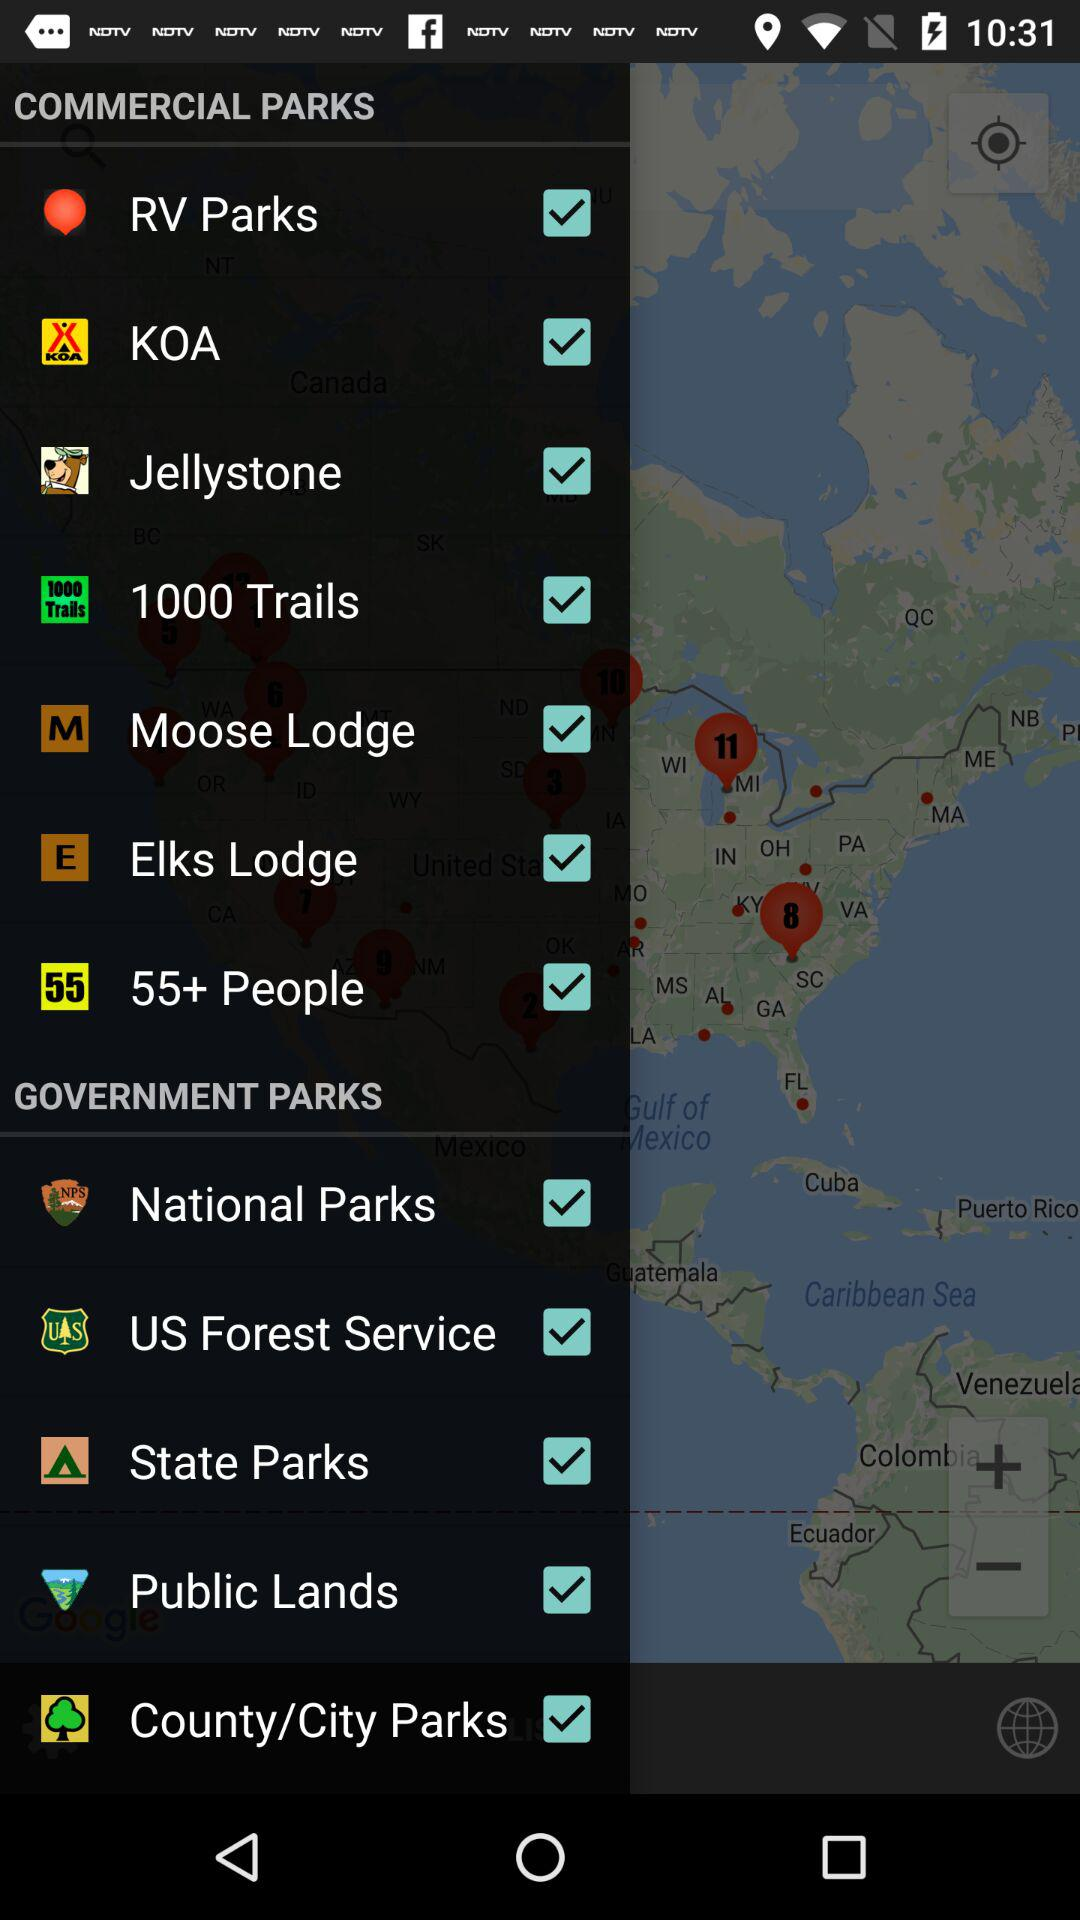Which are the selected Commercial Parks? The selected commercial parks are "RV Parks", "KOA", "Jellystone", "1000 Trails", "Moose Lodge", "Elks Lodge" and "55+ People". 